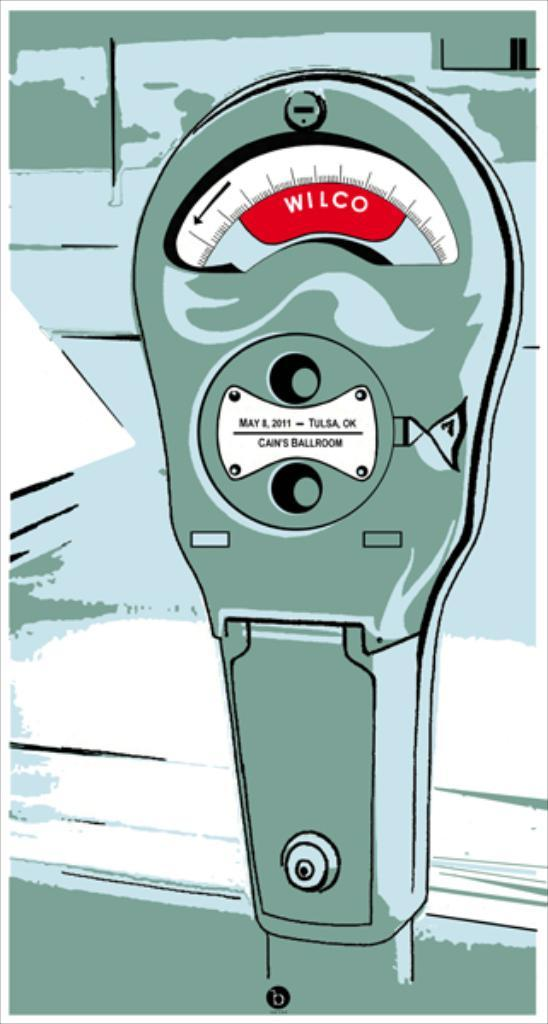Provide a one-sentence caption for the provided image. A graphic for an old Wilco parking meter has a small plaque for Cann's Ballroom in Tulsa, OK. 